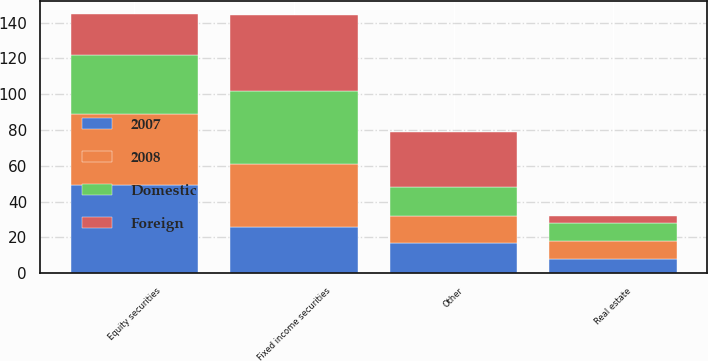Convert chart to OTSL. <chart><loc_0><loc_0><loc_500><loc_500><stacked_bar_chart><ecel><fcel>Equity securities<fcel>Fixed income securities<fcel>Real estate<fcel>Other<nl><fcel>2008<fcel>40<fcel>35<fcel>10<fcel>15<nl><fcel>Foreign<fcel>23<fcel>42<fcel>4<fcel>31<nl><fcel>Domestic<fcel>33<fcel>41<fcel>10<fcel>16<nl><fcel>2007<fcel>49<fcel>26<fcel>8<fcel>17<nl></chart> 